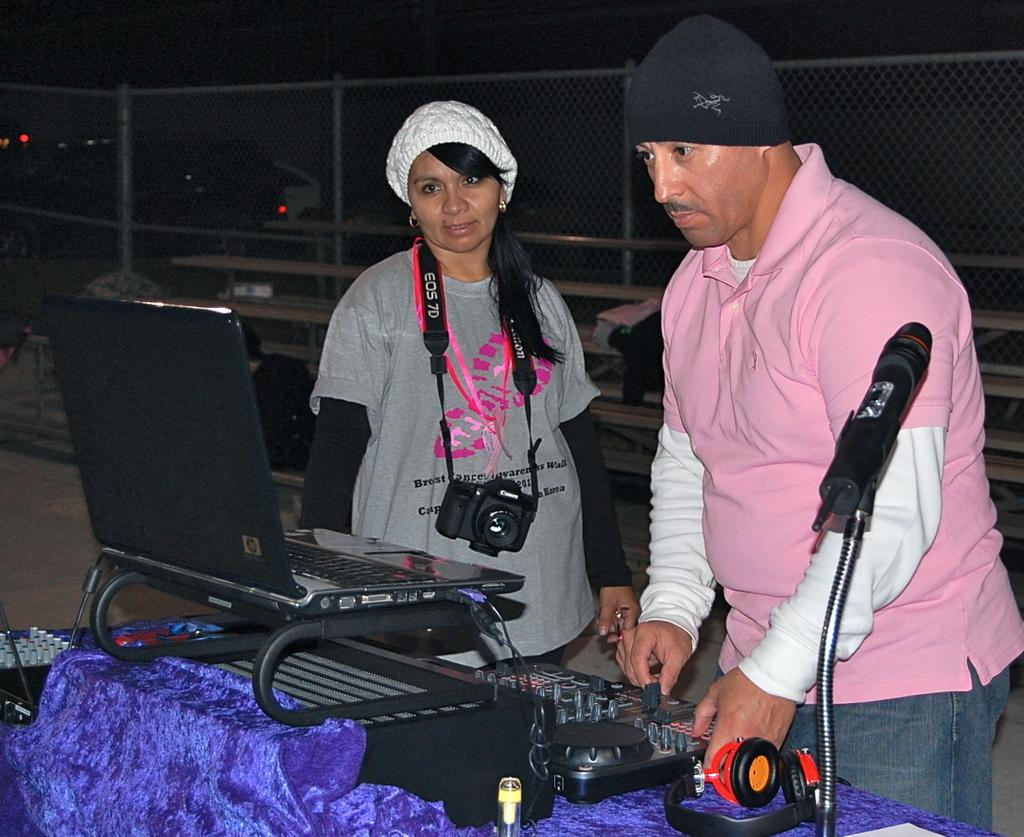How many people are in the image? There are two people in the image. What device is visible in the image? A camera is visible in the image. What electronic device is present in the image? A laptop is present in the image. What type of material is in the image? There is cloth in the image. What objects are present in the image that are used for communication or recording? Devices present in the image include a camera, a laptop, and a microphone (mic). What is the purpose of the fencing net in the image? The fencing net in the image is likely used for sports or recreational activities. Can you describe the unspecified objects in the image? Unfortunately, the facts provided do not specify the nature of the unspecified objects in the image. What is the color of the background in the image? The background of the image is dark. How many rabbits can be seen in the image? There are no rabbits present in the image. What is the amount of neck visible in the image? There is no specific reference to necks in the image, so it is not possible to determine the amount of neck visible. 